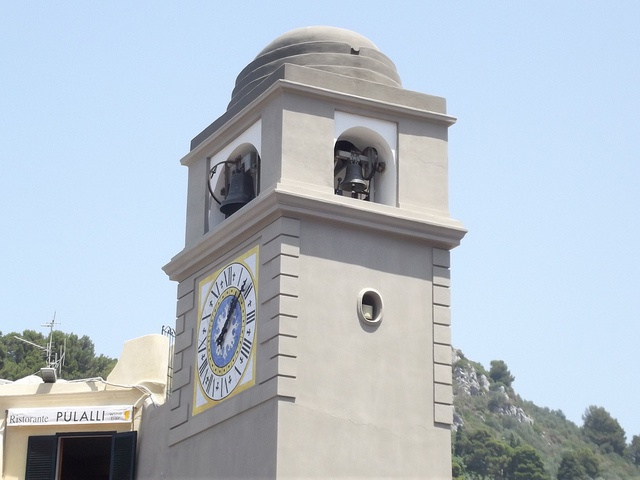Describe the objects in this image and their specific colors. I can see a clock in lightblue, darkgray, tan, and lightgray tones in this image. 